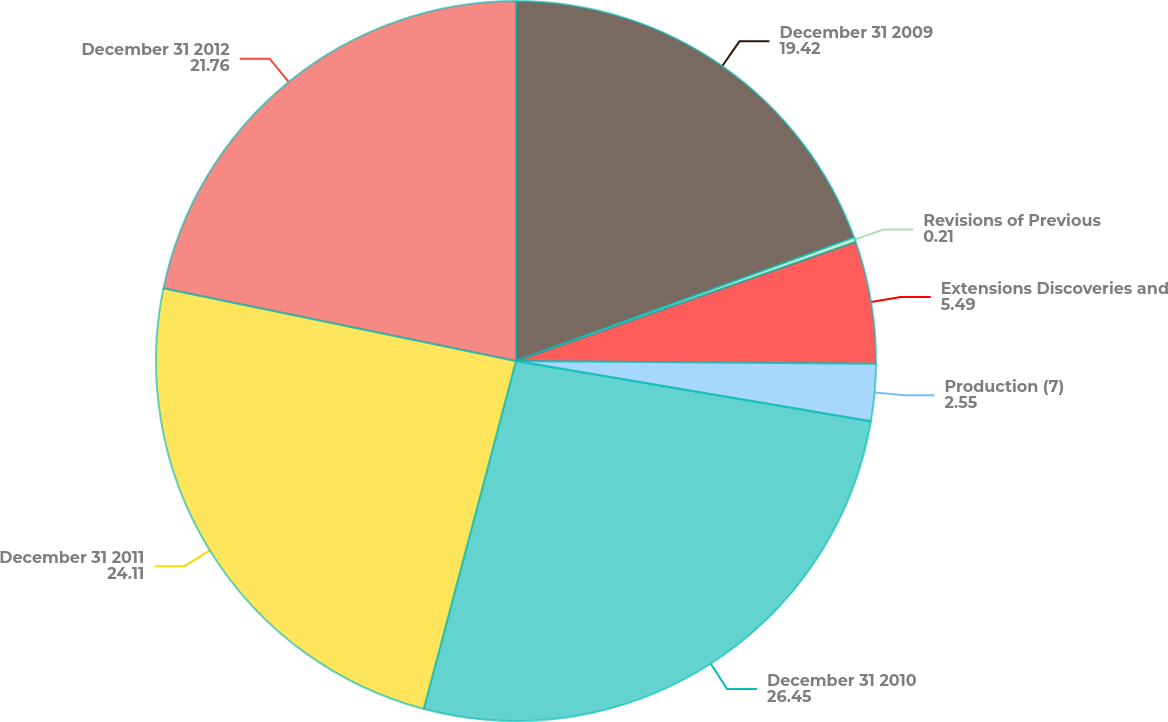Convert chart to OTSL. <chart><loc_0><loc_0><loc_500><loc_500><pie_chart><fcel>December 31 2009<fcel>Revisions of Previous<fcel>Extensions Discoveries and<fcel>Production (7)<fcel>December 31 2010<fcel>December 31 2011<fcel>December 31 2012<nl><fcel>19.42%<fcel>0.21%<fcel>5.49%<fcel>2.55%<fcel>26.45%<fcel>24.11%<fcel>21.76%<nl></chart> 